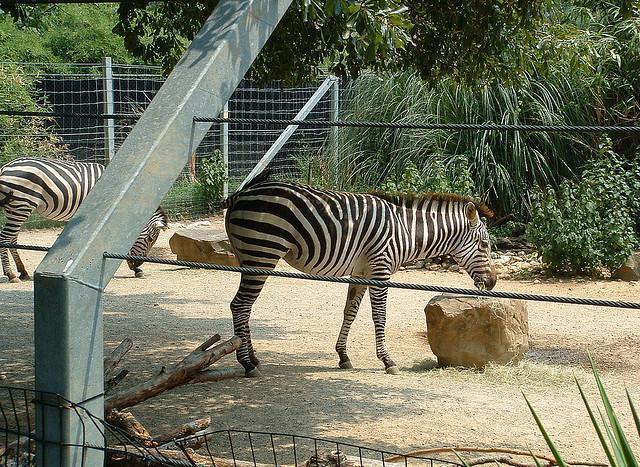How many zebras are there?
Give a very brief answer. 2. How many rocks?
Give a very brief answer. 2. How many zebras can be seen?
Give a very brief answer. 2. 